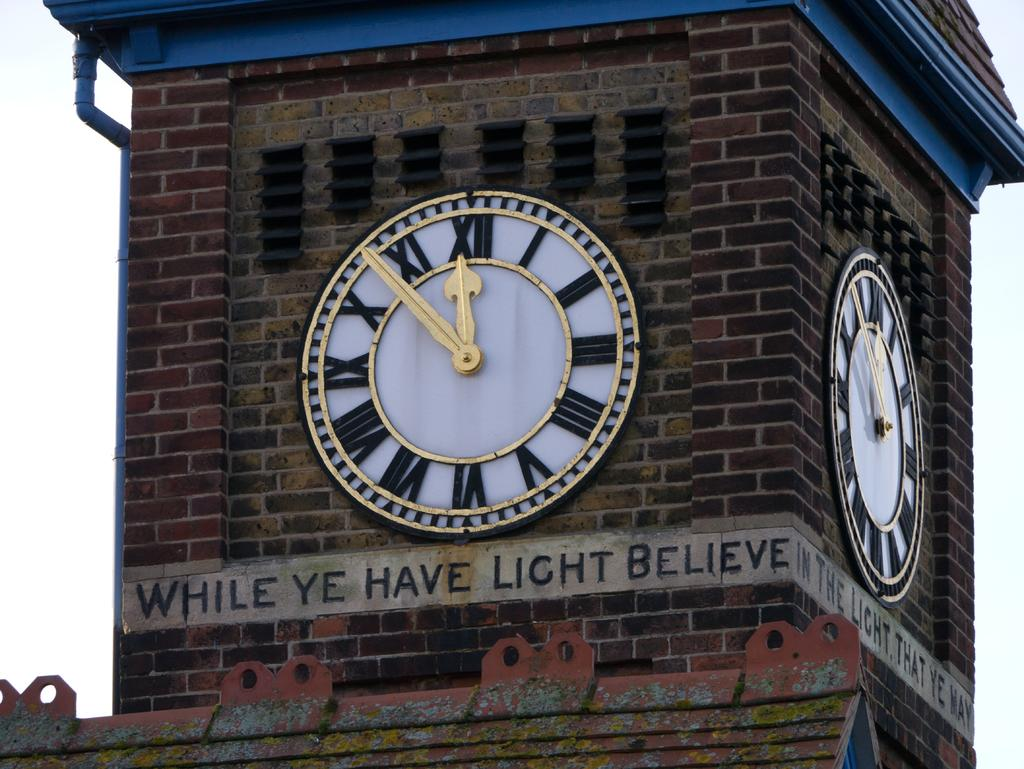<image>
Share a concise interpretation of the image provided. A brick clock tower says While Ye Have Light Believe. 